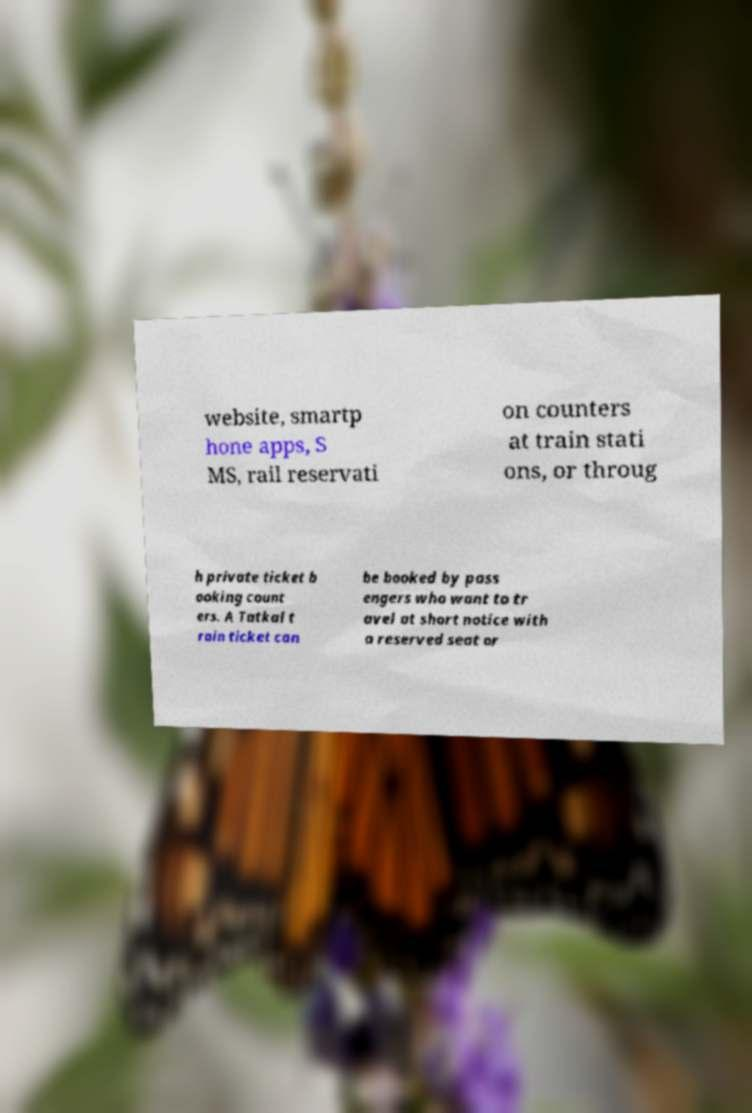There's text embedded in this image that I need extracted. Can you transcribe it verbatim? website, smartp hone apps, S MS, rail reservati on counters at train stati ons, or throug h private ticket b ooking count ers. A Tatkal t rain ticket can be booked by pass engers who want to tr avel at short notice with a reserved seat or 